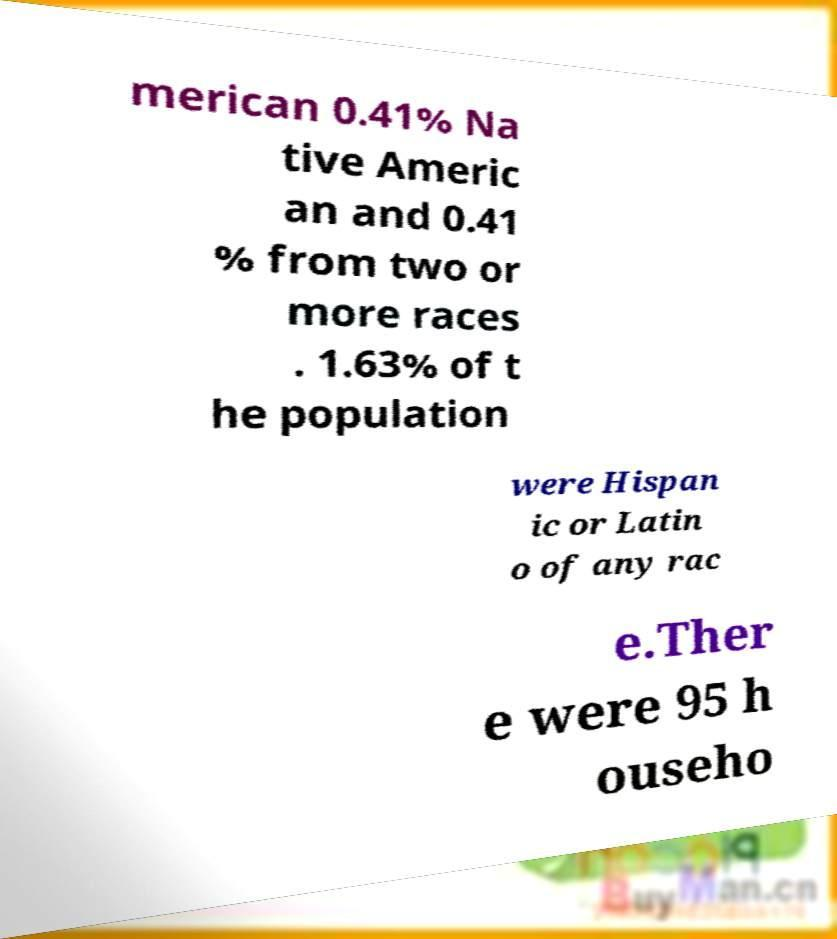There's text embedded in this image that I need extracted. Can you transcribe it verbatim? merican 0.41% Na tive Americ an and 0.41 % from two or more races . 1.63% of t he population were Hispan ic or Latin o of any rac e.Ther e were 95 h ouseho 